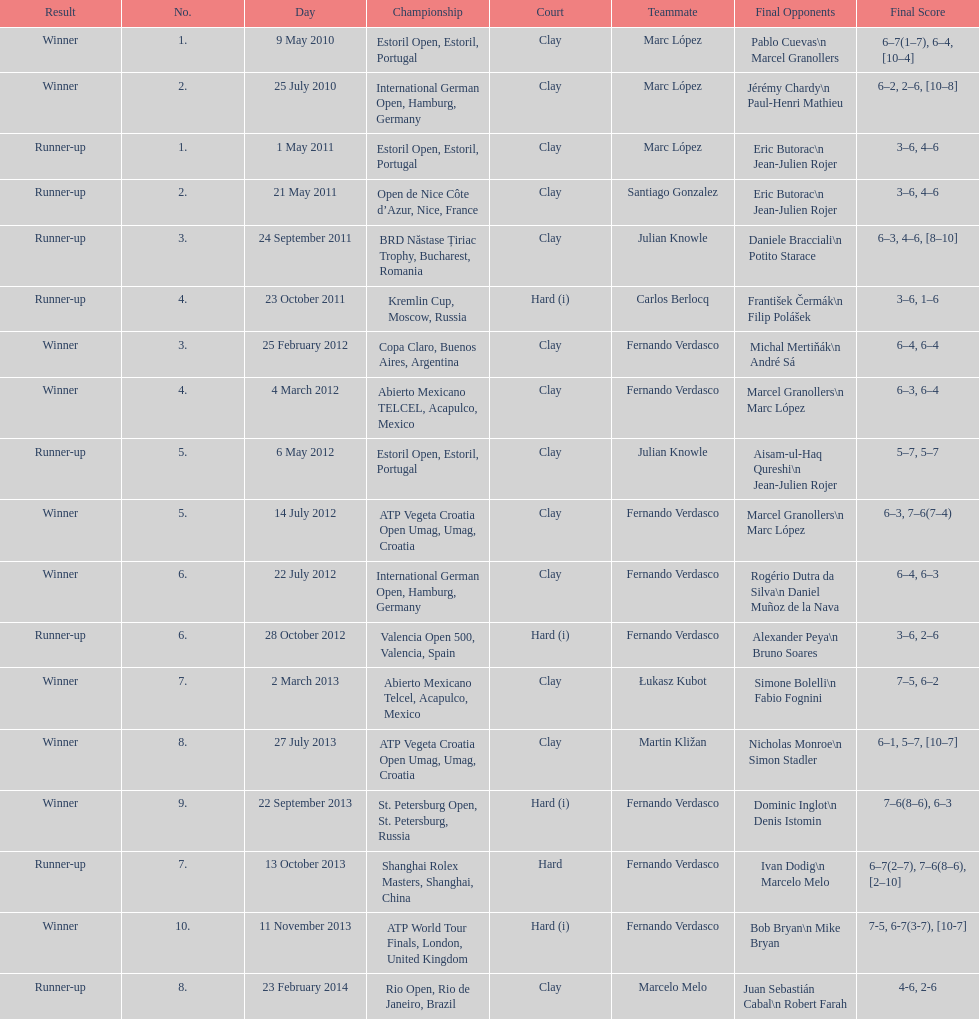Who was this player's next partner after playing with marc lopez in may 2011? Santiago Gonzalez. 